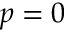Convert formula to latex. <formula><loc_0><loc_0><loc_500><loc_500>p = 0</formula> 